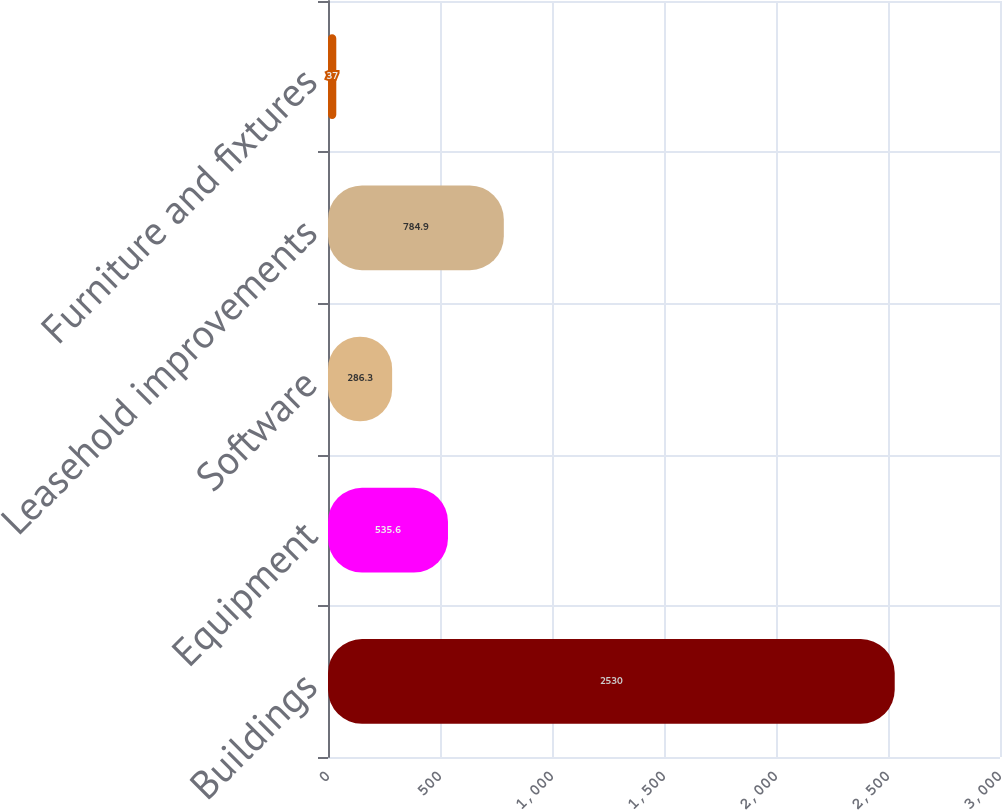<chart> <loc_0><loc_0><loc_500><loc_500><bar_chart><fcel>Buildings<fcel>Equipment<fcel>Software<fcel>Leasehold improvements<fcel>Furniture and fixtures<nl><fcel>2530<fcel>535.6<fcel>286.3<fcel>784.9<fcel>37<nl></chart> 